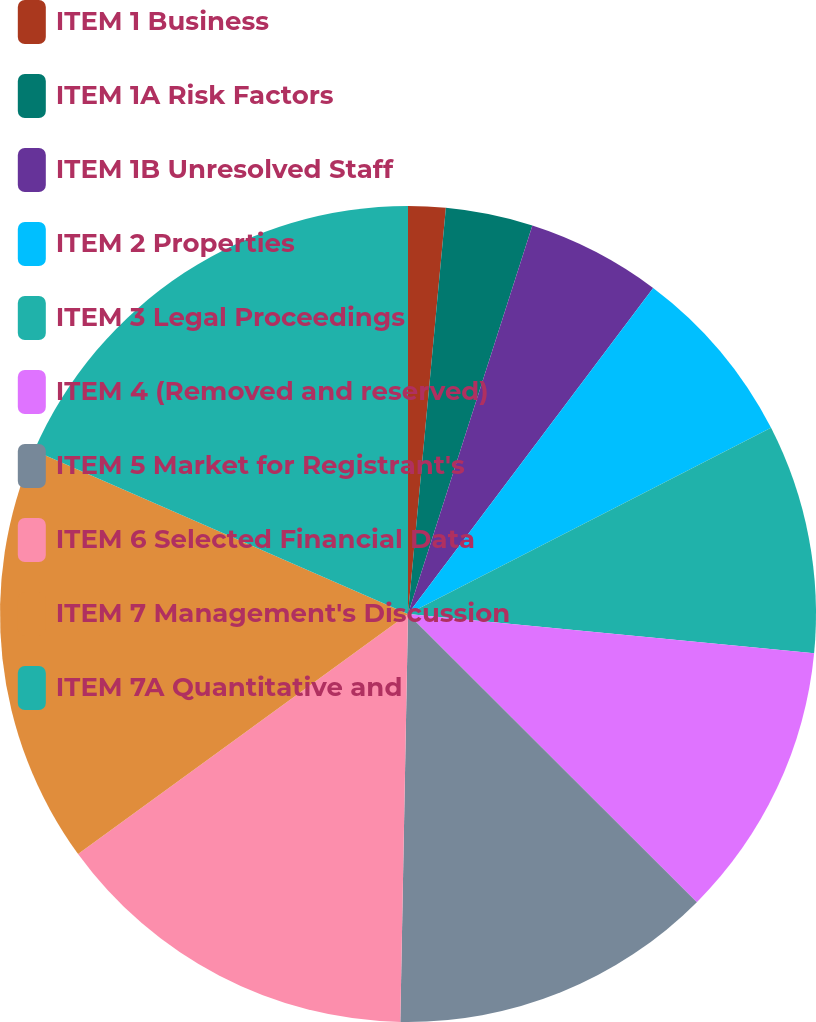<chart> <loc_0><loc_0><loc_500><loc_500><pie_chart><fcel>ITEM 1 Business<fcel>ITEM 1A Risk Factors<fcel>ITEM 1B Unresolved Staff<fcel>ITEM 2 Properties<fcel>ITEM 3 Legal Proceedings<fcel>ITEM 4 (Removed and reserved)<fcel>ITEM 5 Market for Registrant's<fcel>ITEM 6 Selected Financial Data<fcel>ITEM 7 Management's Discussion<fcel>ITEM 7A Quantitative and<nl><fcel>1.48%<fcel>3.45%<fcel>5.33%<fcel>7.2%<fcel>9.07%<fcel>10.95%<fcel>12.82%<fcel>14.69%<fcel>16.57%<fcel>18.44%<nl></chart> 